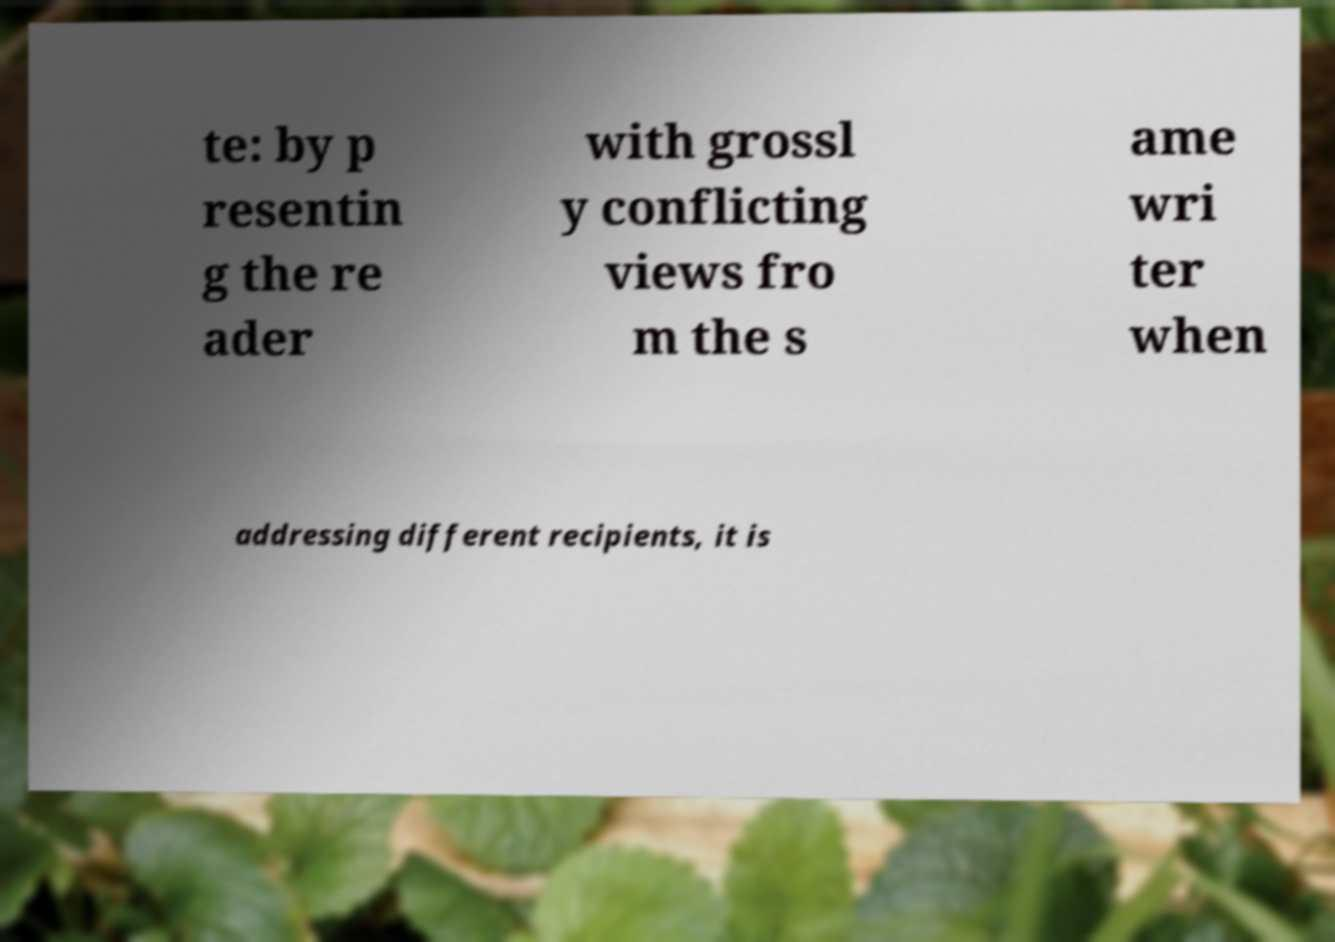Can you accurately transcribe the text from the provided image for me? te: by p resentin g the re ader with grossl y conflicting views fro m the s ame wri ter when addressing different recipients, it is 